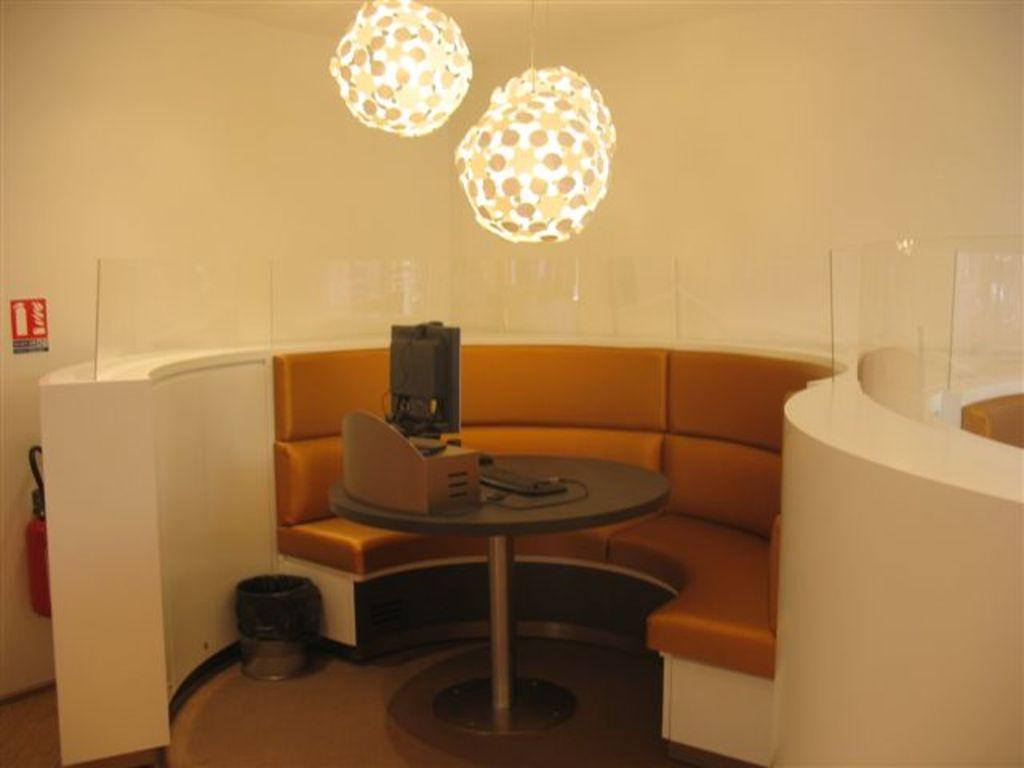Could you give a brief overview of what you see in this image? In this image I see the couch over here and I see a table on which there is a monitor, keyboard and a thing over here and I see the lights and I see the glasses and the cream color wall and I see the sign board and I see the fire extinguisher over here and I see a bin over here. 